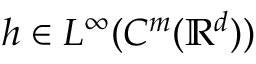Convert formula to latex. <formula><loc_0><loc_0><loc_500><loc_500>h \in L ^ { \infty } ( C ^ { m } ( { \mathbb { R } } ^ { d } ) )</formula> 